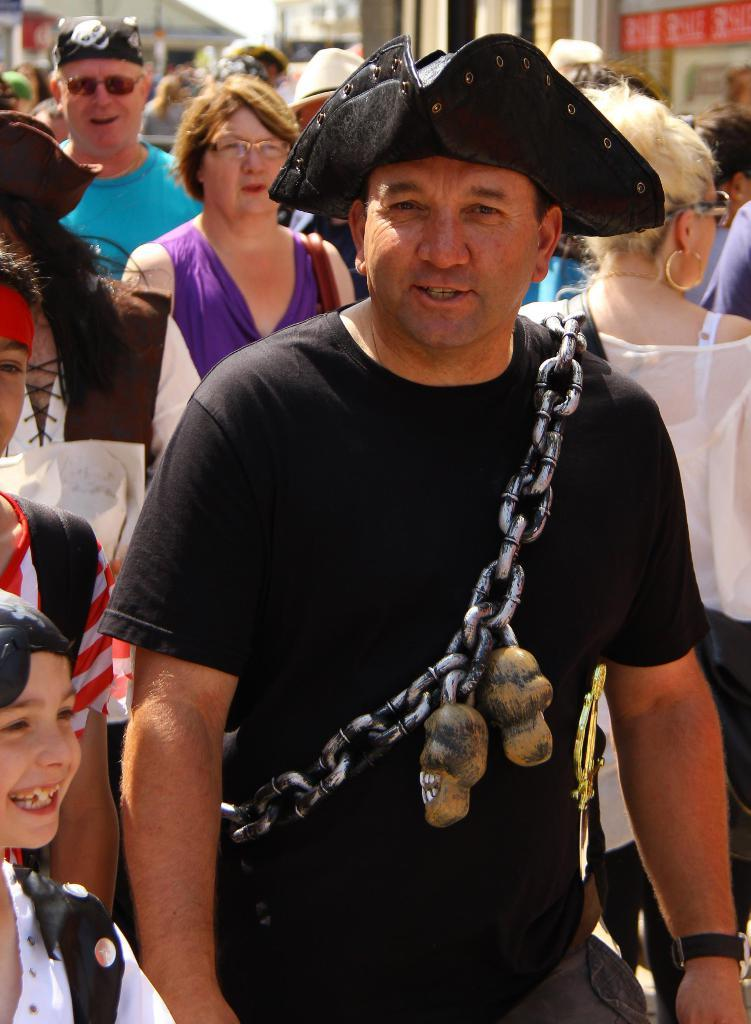How many people are in the image? There is a group of persons in the image. Can you describe the clothing of one of the men? There is a man wearing a hat in the image. What type of accessory is worn by another man? There is a man wearing a metal chain in the image. What can be seen in the distance behind the group of persons? There are buildings in the background of the image. What design is featured on the notebook held by one of the persons in the image? There is no notebook present in the image, so it is not possible to determine the design featured on it. 